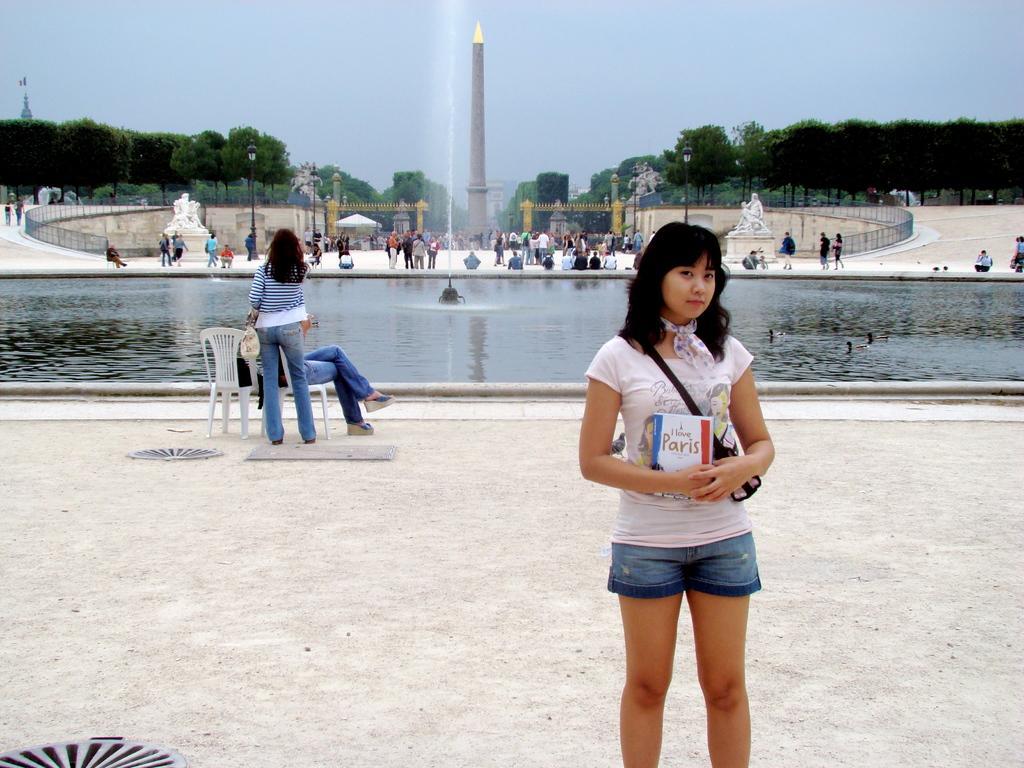How would you summarize this image in a sentence or two? In this image I can see a woman wearing white and blue colored dress is standing and holding a book in her hand. In the background I can see the fountain, few persons standing, few persons sitting, the water, the railing, few statues which are white in color, a huge gate, few trees , few buildings and the sky. 